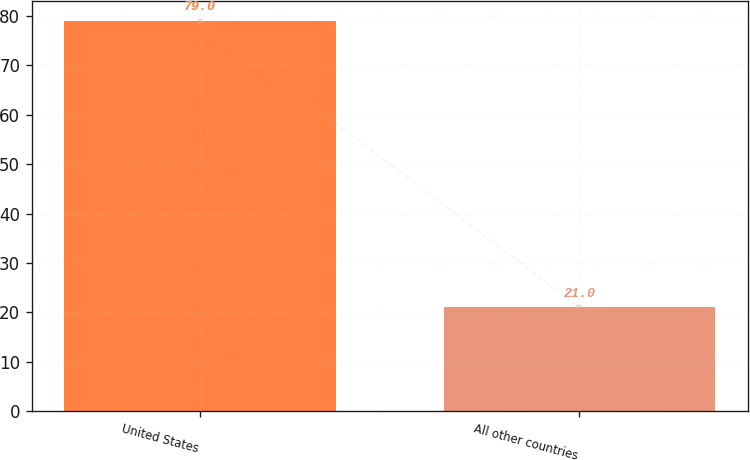Convert chart. <chart><loc_0><loc_0><loc_500><loc_500><bar_chart><fcel>United States<fcel>All other countries<nl><fcel>79<fcel>21<nl></chart> 